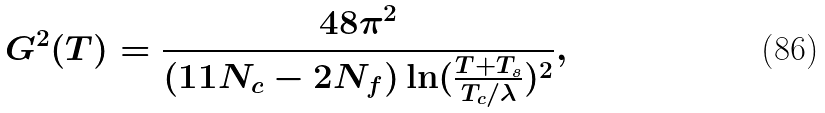Convert formula to latex. <formula><loc_0><loc_0><loc_500><loc_500>G ^ { 2 } ( T ) = \frac { 4 8 \pi ^ { 2 } } { ( 1 1 N _ { c } - 2 N _ { f } ) \ln ( \frac { T + T _ { s } } { T _ { c } / \lambda } ) ^ { 2 } } ,</formula> 